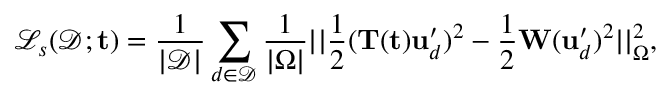<formula> <loc_0><loc_0><loc_500><loc_500>\mathcal { L } _ { s } ( \mathcal { D } ; t ) = \frac { 1 } { | \mathcal { D } | } \sum _ { d \in \mathcal { D } } \frac { 1 } { | \Omega | } | | \frac { 1 } { 2 } ( T ( t ) u _ { d } ^ { \prime } ) ^ { 2 } - \frac { 1 } { 2 } W ( u _ { d } ^ { \prime } ) ^ { 2 } | | _ { \Omega } ^ { 2 } ,</formula> 